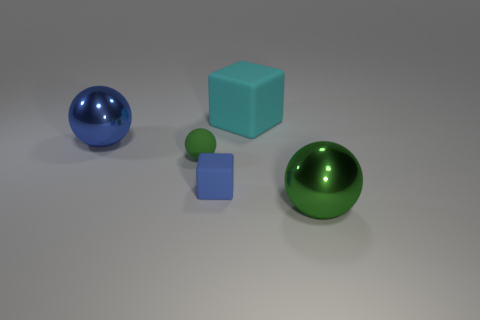Can you describe the shapes and colors visible in the image? Certainly! The image displays a collection of four objects with distinct shapes and colors. You can see two spheres, with one sphere exhibiting a shiny blue color and the other a reflective green. There are also two cubes, one larger in a light cyan tone and a smaller one in purple. The setting appears to be a nondescript gray surface with a soft shadowing effect, suggesting a source of light is present but not visible in the frame. 